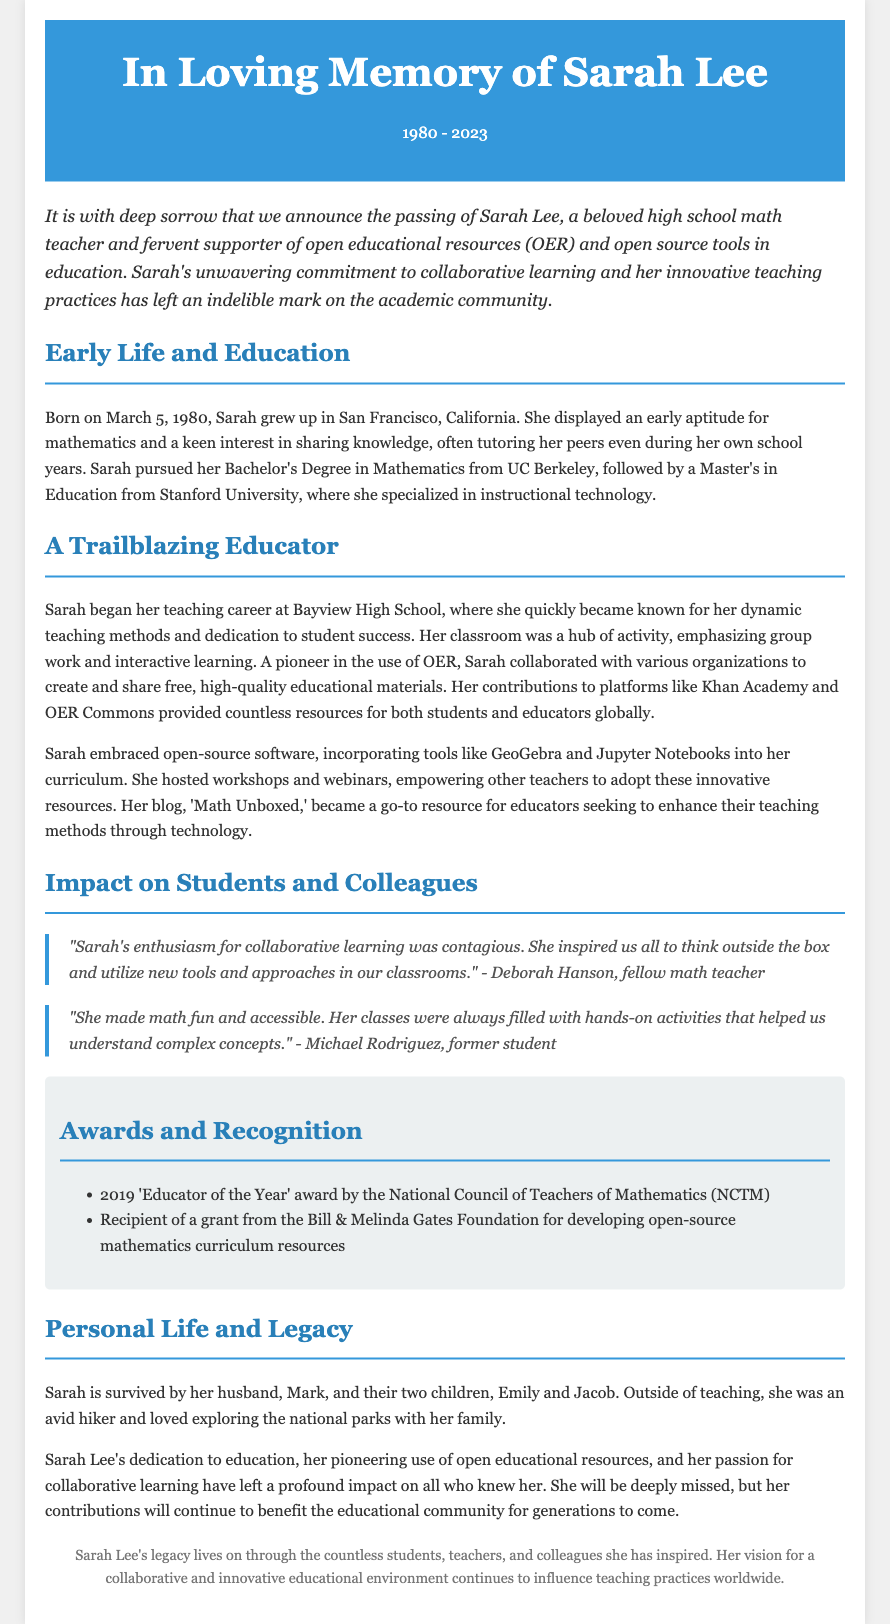what was Sarah Lee's profession? The document states that Sarah Lee was a high school math teacher.
Answer: high school math teacher when was Sarah Lee born? The document notes that Sarah Lee was born on March 5, 1980.
Answer: March 5, 1980 which university did Sarah receive her Bachelor's degree from? The document mentions that Sarah pursued her Bachelor's Degree in Mathematics from UC Berkeley.
Answer: UC Berkeley what innovative tools did Sarah incorporate into her curriculum? The document lists GeoGebra and Jupyter Notebooks as tools Sarah embraced.
Answer: GeoGebra and Jupyter Notebooks who described Sarah's enthusiasm for collaborative learning? The document quotes Deborah Hanson, a fellow math teacher, regarding Sarah's enthusiasm.
Answer: Deborah Hanson what major award did Sarah receive in 2019? The document states that Sarah received the 'Educator of the Year' award by the NCTM in 2019.
Answer: 'Educator of the Year' how many children did Sarah have? The document mentions that she is survived by two children, Emily and Jacob.
Answer: two children which foundation granted Sarah funding for developing resources? The document refers to the Bill & Melinda Gates Foundation as the entity that granted funding to Sarah.
Answer: Bill & Melinda Gates Foundation what was the title of Sarah's blog? The document indicates that her blog was titled 'Math Unboxed.'
Answer: Math Unboxed 